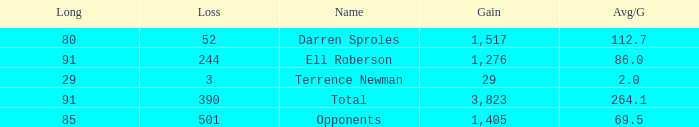When the player gained below 1,405 yards and lost over 390 yards, what's the sum of the long yards? None. 